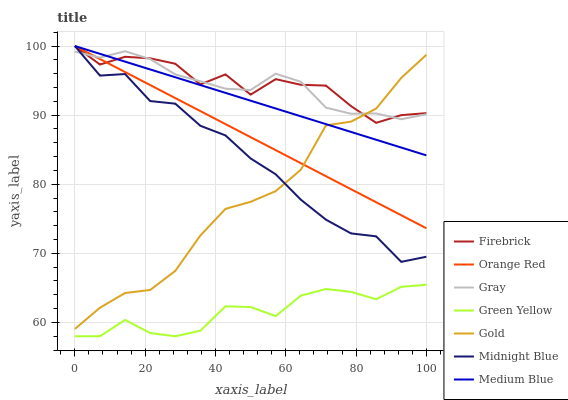Does Green Yellow have the minimum area under the curve?
Answer yes or no. Yes. Does Firebrick have the maximum area under the curve?
Answer yes or no. Yes. Does Midnight Blue have the minimum area under the curve?
Answer yes or no. No. Does Midnight Blue have the maximum area under the curve?
Answer yes or no. No. Is Medium Blue the smoothest?
Answer yes or no. Yes. Is Firebrick the roughest?
Answer yes or no. Yes. Is Midnight Blue the smoothest?
Answer yes or no. No. Is Midnight Blue the roughest?
Answer yes or no. No. Does Green Yellow have the lowest value?
Answer yes or no. Yes. Does Midnight Blue have the lowest value?
Answer yes or no. No. Does Orange Red have the highest value?
Answer yes or no. Yes. Does Gold have the highest value?
Answer yes or no. No. Is Green Yellow less than Gold?
Answer yes or no. Yes. Is Midnight Blue greater than Green Yellow?
Answer yes or no. Yes. Does Firebrick intersect Gray?
Answer yes or no. Yes. Is Firebrick less than Gray?
Answer yes or no. No. Is Firebrick greater than Gray?
Answer yes or no. No. Does Green Yellow intersect Gold?
Answer yes or no. No. 